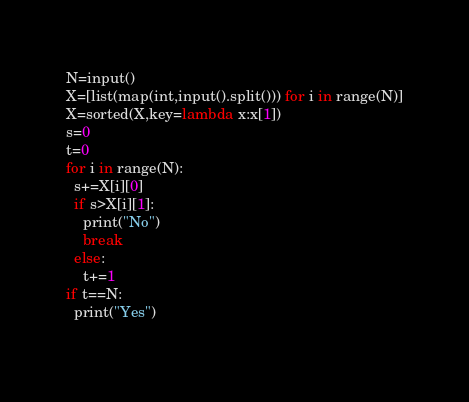<code> <loc_0><loc_0><loc_500><loc_500><_Python_>N=input()
X=[list(map(int,input().split())) for i in range(N)]
X=sorted(X,key=lambda x:x[1])
s=0
t=0
for i in range(N):
  s+=X[i][0]
  if s>X[i][1]:
    print("No")
    break
  else:
    t+=1
if t==N:
  print("Yes")
    </code> 